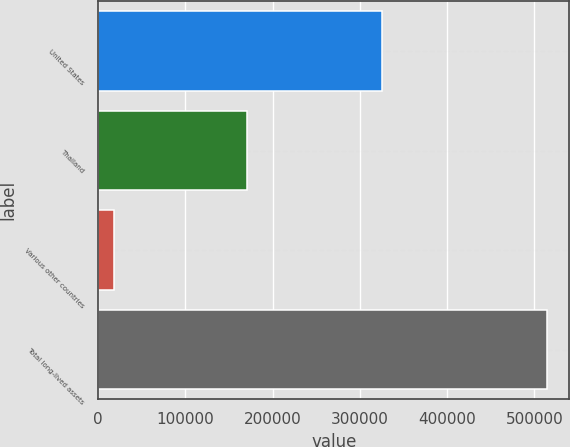<chart> <loc_0><loc_0><loc_500><loc_500><bar_chart><fcel>United States<fcel>Thailand<fcel>Various other countries<fcel>Total long-lived assets<nl><fcel>325326<fcel>171100<fcel>18118<fcel>514544<nl></chart> 